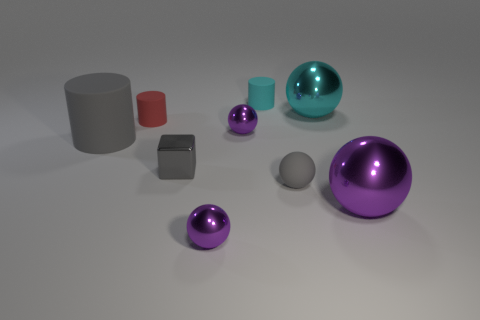What is the shape of the gray metal object?
Keep it short and to the point. Cube. There is a sphere that is to the right of the large cyan shiny thing right of the small metallic object that is behind the shiny block; what is its material?
Provide a succinct answer. Metal. What material is the cylinder that is the same color as the tiny rubber ball?
Offer a very short reply. Rubber. What number of objects are small matte objects or small purple shiny things?
Give a very brief answer. 5. Are the thing in front of the large purple shiny thing and the large cyan sphere made of the same material?
Your response must be concise. Yes. How many things are shiny spheres that are in front of the small shiny cube or red cylinders?
Keep it short and to the point. 3. There is a tiny sphere that is the same material as the large gray object; what is its color?
Offer a terse response. Gray. Is there another red rubber cylinder that has the same size as the red matte cylinder?
Provide a short and direct response. No. There is a small cube in front of the big gray rubber thing; is its color the same as the small matte ball?
Give a very brief answer. Yes. What color is the tiny thing that is in front of the tiny red object and behind the big matte object?
Give a very brief answer. Purple. 